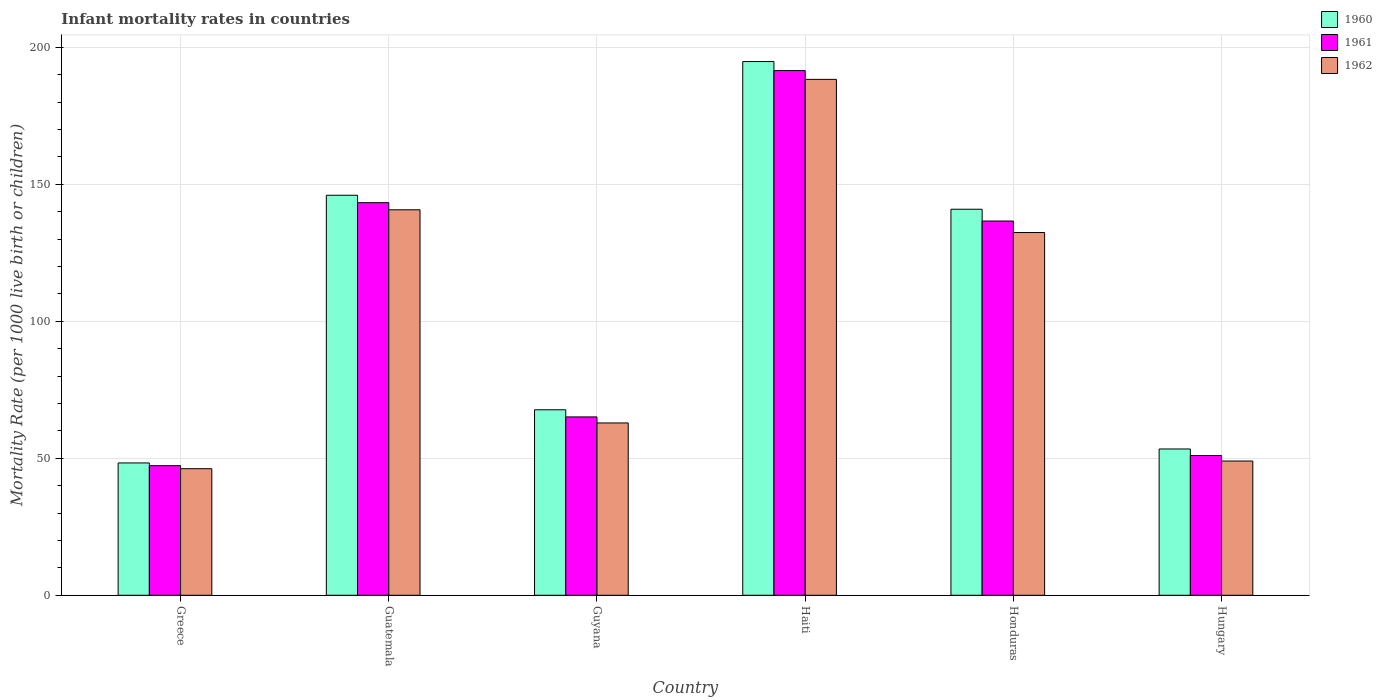How many different coloured bars are there?
Keep it short and to the point. 3. How many groups of bars are there?
Your answer should be compact. 6. Are the number of bars per tick equal to the number of legend labels?
Your answer should be compact. Yes. How many bars are there on the 1st tick from the right?
Provide a short and direct response. 3. What is the infant mortality rate in 1962 in Honduras?
Give a very brief answer. 132.4. Across all countries, what is the maximum infant mortality rate in 1960?
Offer a terse response. 194.8. Across all countries, what is the minimum infant mortality rate in 1961?
Ensure brevity in your answer.  47.3. In which country was the infant mortality rate in 1962 maximum?
Offer a very short reply. Haiti. In which country was the infant mortality rate in 1961 minimum?
Offer a very short reply. Greece. What is the total infant mortality rate in 1960 in the graph?
Ensure brevity in your answer.  651.1. What is the difference between the infant mortality rate in 1962 in Greece and that in Haiti?
Make the answer very short. -142.1. What is the difference between the infant mortality rate in 1961 in Greece and the infant mortality rate in 1960 in Guyana?
Keep it short and to the point. -20.4. What is the average infant mortality rate in 1962 per country?
Offer a terse response. 103.25. In how many countries, is the infant mortality rate in 1962 greater than 70?
Offer a terse response. 3. What is the ratio of the infant mortality rate in 1961 in Greece to that in Haiti?
Provide a succinct answer. 0.25. Is the difference between the infant mortality rate in 1962 in Greece and Guatemala greater than the difference between the infant mortality rate in 1960 in Greece and Guatemala?
Offer a very short reply. Yes. What is the difference between the highest and the second highest infant mortality rate in 1960?
Your answer should be compact. 53.9. What is the difference between the highest and the lowest infant mortality rate in 1961?
Offer a terse response. 144.2. In how many countries, is the infant mortality rate in 1961 greater than the average infant mortality rate in 1961 taken over all countries?
Your answer should be very brief. 3. What does the 1st bar from the right in Honduras represents?
Ensure brevity in your answer.  1962. Is it the case that in every country, the sum of the infant mortality rate in 1960 and infant mortality rate in 1961 is greater than the infant mortality rate in 1962?
Provide a short and direct response. Yes. How many countries are there in the graph?
Your answer should be very brief. 6. What is the difference between two consecutive major ticks on the Y-axis?
Offer a very short reply. 50. Are the values on the major ticks of Y-axis written in scientific E-notation?
Offer a very short reply. No. Does the graph contain any zero values?
Provide a short and direct response. No. How are the legend labels stacked?
Your answer should be very brief. Vertical. What is the title of the graph?
Offer a very short reply. Infant mortality rates in countries. What is the label or title of the X-axis?
Provide a succinct answer. Country. What is the label or title of the Y-axis?
Provide a succinct answer. Mortality Rate (per 1000 live birth or children). What is the Mortality Rate (per 1000 live birth or children) in 1960 in Greece?
Your answer should be compact. 48.3. What is the Mortality Rate (per 1000 live birth or children) in 1961 in Greece?
Give a very brief answer. 47.3. What is the Mortality Rate (per 1000 live birth or children) of 1962 in Greece?
Offer a very short reply. 46.2. What is the Mortality Rate (per 1000 live birth or children) of 1960 in Guatemala?
Make the answer very short. 146. What is the Mortality Rate (per 1000 live birth or children) of 1961 in Guatemala?
Your answer should be compact. 143.3. What is the Mortality Rate (per 1000 live birth or children) of 1962 in Guatemala?
Your answer should be compact. 140.7. What is the Mortality Rate (per 1000 live birth or children) of 1960 in Guyana?
Make the answer very short. 67.7. What is the Mortality Rate (per 1000 live birth or children) of 1961 in Guyana?
Provide a short and direct response. 65.1. What is the Mortality Rate (per 1000 live birth or children) in 1962 in Guyana?
Offer a very short reply. 62.9. What is the Mortality Rate (per 1000 live birth or children) in 1960 in Haiti?
Make the answer very short. 194.8. What is the Mortality Rate (per 1000 live birth or children) of 1961 in Haiti?
Your response must be concise. 191.5. What is the Mortality Rate (per 1000 live birth or children) in 1962 in Haiti?
Your answer should be very brief. 188.3. What is the Mortality Rate (per 1000 live birth or children) of 1960 in Honduras?
Your answer should be very brief. 140.9. What is the Mortality Rate (per 1000 live birth or children) of 1961 in Honduras?
Give a very brief answer. 136.6. What is the Mortality Rate (per 1000 live birth or children) of 1962 in Honduras?
Offer a very short reply. 132.4. What is the Mortality Rate (per 1000 live birth or children) in 1960 in Hungary?
Make the answer very short. 53.4. What is the Mortality Rate (per 1000 live birth or children) of 1962 in Hungary?
Your answer should be very brief. 49. Across all countries, what is the maximum Mortality Rate (per 1000 live birth or children) in 1960?
Your answer should be very brief. 194.8. Across all countries, what is the maximum Mortality Rate (per 1000 live birth or children) in 1961?
Provide a succinct answer. 191.5. Across all countries, what is the maximum Mortality Rate (per 1000 live birth or children) in 1962?
Provide a succinct answer. 188.3. Across all countries, what is the minimum Mortality Rate (per 1000 live birth or children) in 1960?
Offer a very short reply. 48.3. Across all countries, what is the minimum Mortality Rate (per 1000 live birth or children) of 1961?
Keep it short and to the point. 47.3. Across all countries, what is the minimum Mortality Rate (per 1000 live birth or children) in 1962?
Offer a terse response. 46.2. What is the total Mortality Rate (per 1000 live birth or children) of 1960 in the graph?
Your answer should be compact. 651.1. What is the total Mortality Rate (per 1000 live birth or children) in 1961 in the graph?
Make the answer very short. 634.8. What is the total Mortality Rate (per 1000 live birth or children) of 1962 in the graph?
Keep it short and to the point. 619.5. What is the difference between the Mortality Rate (per 1000 live birth or children) of 1960 in Greece and that in Guatemala?
Your response must be concise. -97.7. What is the difference between the Mortality Rate (per 1000 live birth or children) of 1961 in Greece and that in Guatemala?
Give a very brief answer. -96. What is the difference between the Mortality Rate (per 1000 live birth or children) in 1962 in Greece and that in Guatemala?
Your answer should be compact. -94.5. What is the difference between the Mortality Rate (per 1000 live birth or children) in 1960 in Greece and that in Guyana?
Provide a short and direct response. -19.4. What is the difference between the Mortality Rate (per 1000 live birth or children) of 1961 in Greece and that in Guyana?
Keep it short and to the point. -17.8. What is the difference between the Mortality Rate (per 1000 live birth or children) in 1962 in Greece and that in Guyana?
Give a very brief answer. -16.7. What is the difference between the Mortality Rate (per 1000 live birth or children) in 1960 in Greece and that in Haiti?
Give a very brief answer. -146.5. What is the difference between the Mortality Rate (per 1000 live birth or children) in 1961 in Greece and that in Haiti?
Give a very brief answer. -144.2. What is the difference between the Mortality Rate (per 1000 live birth or children) of 1962 in Greece and that in Haiti?
Give a very brief answer. -142.1. What is the difference between the Mortality Rate (per 1000 live birth or children) of 1960 in Greece and that in Honduras?
Your answer should be very brief. -92.6. What is the difference between the Mortality Rate (per 1000 live birth or children) of 1961 in Greece and that in Honduras?
Your answer should be compact. -89.3. What is the difference between the Mortality Rate (per 1000 live birth or children) of 1962 in Greece and that in Honduras?
Your answer should be very brief. -86.2. What is the difference between the Mortality Rate (per 1000 live birth or children) of 1960 in Greece and that in Hungary?
Offer a very short reply. -5.1. What is the difference between the Mortality Rate (per 1000 live birth or children) of 1962 in Greece and that in Hungary?
Provide a succinct answer. -2.8. What is the difference between the Mortality Rate (per 1000 live birth or children) in 1960 in Guatemala and that in Guyana?
Your answer should be very brief. 78.3. What is the difference between the Mortality Rate (per 1000 live birth or children) of 1961 in Guatemala and that in Guyana?
Provide a short and direct response. 78.2. What is the difference between the Mortality Rate (per 1000 live birth or children) in 1962 in Guatemala and that in Guyana?
Your response must be concise. 77.8. What is the difference between the Mortality Rate (per 1000 live birth or children) in 1960 in Guatemala and that in Haiti?
Provide a succinct answer. -48.8. What is the difference between the Mortality Rate (per 1000 live birth or children) of 1961 in Guatemala and that in Haiti?
Your response must be concise. -48.2. What is the difference between the Mortality Rate (per 1000 live birth or children) in 1962 in Guatemala and that in Haiti?
Offer a very short reply. -47.6. What is the difference between the Mortality Rate (per 1000 live birth or children) of 1962 in Guatemala and that in Honduras?
Your response must be concise. 8.3. What is the difference between the Mortality Rate (per 1000 live birth or children) of 1960 in Guatemala and that in Hungary?
Provide a succinct answer. 92.6. What is the difference between the Mortality Rate (per 1000 live birth or children) in 1961 in Guatemala and that in Hungary?
Provide a short and direct response. 92.3. What is the difference between the Mortality Rate (per 1000 live birth or children) of 1962 in Guatemala and that in Hungary?
Offer a terse response. 91.7. What is the difference between the Mortality Rate (per 1000 live birth or children) in 1960 in Guyana and that in Haiti?
Ensure brevity in your answer.  -127.1. What is the difference between the Mortality Rate (per 1000 live birth or children) in 1961 in Guyana and that in Haiti?
Keep it short and to the point. -126.4. What is the difference between the Mortality Rate (per 1000 live birth or children) in 1962 in Guyana and that in Haiti?
Make the answer very short. -125.4. What is the difference between the Mortality Rate (per 1000 live birth or children) of 1960 in Guyana and that in Honduras?
Provide a short and direct response. -73.2. What is the difference between the Mortality Rate (per 1000 live birth or children) in 1961 in Guyana and that in Honduras?
Your response must be concise. -71.5. What is the difference between the Mortality Rate (per 1000 live birth or children) in 1962 in Guyana and that in Honduras?
Provide a short and direct response. -69.5. What is the difference between the Mortality Rate (per 1000 live birth or children) in 1960 in Haiti and that in Honduras?
Give a very brief answer. 53.9. What is the difference between the Mortality Rate (per 1000 live birth or children) in 1961 in Haiti and that in Honduras?
Keep it short and to the point. 54.9. What is the difference between the Mortality Rate (per 1000 live birth or children) of 1962 in Haiti and that in Honduras?
Make the answer very short. 55.9. What is the difference between the Mortality Rate (per 1000 live birth or children) of 1960 in Haiti and that in Hungary?
Make the answer very short. 141.4. What is the difference between the Mortality Rate (per 1000 live birth or children) in 1961 in Haiti and that in Hungary?
Your answer should be very brief. 140.5. What is the difference between the Mortality Rate (per 1000 live birth or children) in 1962 in Haiti and that in Hungary?
Keep it short and to the point. 139.3. What is the difference between the Mortality Rate (per 1000 live birth or children) in 1960 in Honduras and that in Hungary?
Your answer should be very brief. 87.5. What is the difference between the Mortality Rate (per 1000 live birth or children) in 1961 in Honduras and that in Hungary?
Ensure brevity in your answer.  85.6. What is the difference between the Mortality Rate (per 1000 live birth or children) in 1962 in Honduras and that in Hungary?
Make the answer very short. 83.4. What is the difference between the Mortality Rate (per 1000 live birth or children) of 1960 in Greece and the Mortality Rate (per 1000 live birth or children) of 1961 in Guatemala?
Keep it short and to the point. -95. What is the difference between the Mortality Rate (per 1000 live birth or children) in 1960 in Greece and the Mortality Rate (per 1000 live birth or children) in 1962 in Guatemala?
Provide a succinct answer. -92.4. What is the difference between the Mortality Rate (per 1000 live birth or children) in 1961 in Greece and the Mortality Rate (per 1000 live birth or children) in 1962 in Guatemala?
Provide a succinct answer. -93.4. What is the difference between the Mortality Rate (per 1000 live birth or children) in 1960 in Greece and the Mortality Rate (per 1000 live birth or children) in 1961 in Guyana?
Keep it short and to the point. -16.8. What is the difference between the Mortality Rate (per 1000 live birth or children) in 1960 in Greece and the Mortality Rate (per 1000 live birth or children) in 1962 in Guyana?
Make the answer very short. -14.6. What is the difference between the Mortality Rate (per 1000 live birth or children) of 1961 in Greece and the Mortality Rate (per 1000 live birth or children) of 1962 in Guyana?
Make the answer very short. -15.6. What is the difference between the Mortality Rate (per 1000 live birth or children) of 1960 in Greece and the Mortality Rate (per 1000 live birth or children) of 1961 in Haiti?
Offer a very short reply. -143.2. What is the difference between the Mortality Rate (per 1000 live birth or children) of 1960 in Greece and the Mortality Rate (per 1000 live birth or children) of 1962 in Haiti?
Provide a short and direct response. -140. What is the difference between the Mortality Rate (per 1000 live birth or children) in 1961 in Greece and the Mortality Rate (per 1000 live birth or children) in 1962 in Haiti?
Offer a very short reply. -141. What is the difference between the Mortality Rate (per 1000 live birth or children) in 1960 in Greece and the Mortality Rate (per 1000 live birth or children) in 1961 in Honduras?
Provide a succinct answer. -88.3. What is the difference between the Mortality Rate (per 1000 live birth or children) of 1960 in Greece and the Mortality Rate (per 1000 live birth or children) of 1962 in Honduras?
Offer a very short reply. -84.1. What is the difference between the Mortality Rate (per 1000 live birth or children) in 1961 in Greece and the Mortality Rate (per 1000 live birth or children) in 1962 in Honduras?
Your answer should be compact. -85.1. What is the difference between the Mortality Rate (per 1000 live birth or children) in 1960 in Greece and the Mortality Rate (per 1000 live birth or children) in 1961 in Hungary?
Your answer should be very brief. -2.7. What is the difference between the Mortality Rate (per 1000 live birth or children) in 1960 in Greece and the Mortality Rate (per 1000 live birth or children) in 1962 in Hungary?
Give a very brief answer. -0.7. What is the difference between the Mortality Rate (per 1000 live birth or children) in 1960 in Guatemala and the Mortality Rate (per 1000 live birth or children) in 1961 in Guyana?
Keep it short and to the point. 80.9. What is the difference between the Mortality Rate (per 1000 live birth or children) of 1960 in Guatemala and the Mortality Rate (per 1000 live birth or children) of 1962 in Guyana?
Provide a short and direct response. 83.1. What is the difference between the Mortality Rate (per 1000 live birth or children) in 1961 in Guatemala and the Mortality Rate (per 1000 live birth or children) in 1962 in Guyana?
Provide a short and direct response. 80.4. What is the difference between the Mortality Rate (per 1000 live birth or children) in 1960 in Guatemala and the Mortality Rate (per 1000 live birth or children) in 1961 in Haiti?
Make the answer very short. -45.5. What is the difference between the Mortality Rate (per 1000 live birth or children) in 1960 in Guatemala and the Mortality Rate (per 1000 live birth or children) in 1962 in Haiti?
Offer a terse response. -42.3. What is the difference between the Mortality Rate (per 1000 live birth or children) in 1961 in Guatemala and the Mortality Rate (per 1000 live birth or children) in 1962 in Haiti?
Make the answer very short. -45. What is the difference between the Mortality Rate (per 1000 live birth or children) in 1960 in Guatemala and the Mortality Rate (per 1000 live birth or children) in 1962 in Honduras?
Give a very brief answer. 13.6. What is the difference between the Mortality Rate (per 1000 live birth or children) in 1961 in Guatemala and the Mortality Rate (per 1000 live birth or children) in 1962 in Honduras?
Your answer should be very brief. 10.9. What is the difference between the Mortality Rate (per 1000 live birth or children) in 1960 in Guatemala and the Mortality Rate (per 1000 live birth or children) in 1962 in Hungary?
Ensure brevity in your answer.  97. What is the difference between the Mortality Rate (per 1000 live birth or children) in 1961 in Guatemala and the Mortality Rate (per 1000 live birth or children) in 1962 in Hungary?
Provide a succinct answer. 94.3. What is the difference between the Mortality Rate (per 1000 live birth or children) of 1960 in Guyana and the Mortality Rate (per 1000 live birth or children) of 1961 in Haiti?
Your answer should be very brief. -123.8. What is the difference between the Mortality Rate (per 1000 live birth or children) of 1960 in Guyana and the Mortality Rate (per 1000 live birth or children) of 1962 in Haiti?
Your answer should be very brief. -120.6. What is the difference between the Mortality Rate (per 1000 live birth or children) of 1961 in Guyana and the Mortality Rate (per 1000 live birth or children) of 1962 in Haiti?
Keep it short and to the point. -123.2. What is the difference between the Mortality Rate (per 1000 live birth or children) of 1960 in Guyana and the Mortality Rate (per 1000 live birth or children) of 1961 in Honduras?
Offer a very short reply. -68.9. What is the difference between the Mortality Rate (per 1000 live birth or children) in 1960 in Guyana and the Mortality Rate (per 1000 live birth or children) in 1962 in Honduras?
Offer a very short reply. -64.7. What is the difference between the Mortality Rate (per 1000 live birth or children) in 1961 in Guyana and the Mortality Rate (per 1000 live birth or children) in 1962 in Honduras?
Ensure brevity in your answer.  -67.3. What is the difference between the Mortality Rate (per 1000 live birth or children) of 1960 in Haiti and the Mortality Rate (per 1000 live birth or children) of 1961 in Honduras?
Make the answer very short. 58.2. What is the difference between the Mortality Rate (per 1000 live birth or children) in 1960 in Haiti and the Mortality Rate (per 1000 live birth or children) in 1962 in Honduras?
Provide a short and direct response. 62.4. What is the difference between the Mortality Rate (per 1000 live birth or children) of 1961 in Haiti and the Mortality Rate (per 1000 live birth or children) of 1962 in Honduras?
Provide a succinct answer. 59.1. What is the difference between the Mortality Rate (per 1000 live birth or children) of 1960 in Haiti and the Mortality Rate (per 1000 live birth or children) of 1961 in Hungary?
Provide a succinct answer. 143.8. What is the difference between the Mortality Rate (per 1000 live birth or children) of 1960 in Haiti and the Mortality Rate (per 1000 live birth or children) of 1962 in Hungary?
Offer a very short reply. 145.8. What is the difference between the Mortality Rate (per 1000 live birth or children) in 1961 in Haiti and the Mortality Rate (per 1000 live birth or children) in 1962 in Hungary?
Your answer should be compact. 142.5. What is the difference between the Mortality Rate (per 1000 live birth or children) in 1960 in Honduras and the Mortality Rate (per 1000 live birth or children) in 1961 in Hungary?
Keep it short and to the point. 89.9. What is the difference between the Mortality Rate (per 1000 live birth or children) of 1960 in Honduras and the Mortality Rate (per 1000 live birth or children) of 1962 in Hungary?
Offer a very short reply. 91.9. What is the difference between the Mortality Rate (per 1000 live birth or children) in 1961 in Honduras and the Mortality Rate (per 1000 live birth or children) in 1962 in Hungary?
Your response must be concise. 87.6. What is the average Mortality Rate (per 1000 live birth or children) of 1960 per country?
Give a very brief answer. 108.52. What is the average Mortality Rate (per 1000 live birth or children) in 1961 per country?
Provide a short and direct response. 105.8. What is the average Mortality Rate (per 1000 live birth or children) of 1962 per country?
Your answer should be compact. 103.25. What is the difference between the Mortality Rate (per 1000 live birth or children) of 1960 and Mortality Rate (per 1000 live birth or children) of 1961 in Greece?
Make the answer very short. 1. What is the difference between the Mortality Rate (per 1000 live birth or children) in 1960 and Mortality Rate (per 1000 live birth or children) in 1962 in Greece?
Your response must be concise. 2.1. What is the difference between the Mortality Rate (per 1000 live birth or children) in 1961 and Mortality Rate (per 1000 live birth or children) in 1962 in Greece?
Keep it short and to the point. 1.1. What is the difference between the Mortality Rate (per 1000 live birth or children) in 1960 and Mortality Rate (per 1000 live birth or children) in 1961 in Guatemala?
Ensure brevity in your answer.  2.7. What is the difference between the Mortality Rate (per 1000 live birth or children) in 1960 and Mortality Rate (per 1000 live birth or children) in 1962 in Guatemala?
Make the answer very short. 5.3. What is the difference between the Mortality Rate (per 1000 live birth or children) in 1961 and Mortality Rate (per 1000 live birth or children) in 1962 in Guatemala?
Ensure brevity in your answer.  2.6. What is the difference between the Mortality Rate (per 1000 live birth or children) in 1961 and Mortality Rate (per 1000 live birth or children) in 1962 in Guyana?
Ensure brevity in your answer.  2.2. What is the difference between the Mortality Rate (per 1000 live birth or children) of 1961 and Mortality Rate (per 1000 live birth or children) of 1962 in Haiti?
Keep it short and to the point. 3.2. What is the difference between the Mortality Rate (per 1000 live birth or children) of 1960 and Mortality Rate (per 1000 live birth or children) of 1962 in Honduras?
Keep it short and to the point. 8.5. What is the difference between the Mortality Rate (per 1000 live birth or children) in 1960 and Mortality Rate (per 1000 live birth or children) in 1961 in Hungary?
Provide a succinct answer. 2.4. What is the ratio of the Mortality Rate (per 1000 live birth or children) of 1960 in Greece to that in Guatemala?
Offer a terse response. 0.33. What is the ratio of the Mortality Rate (per 1000 live birth or children) of 1961 in Greece to that in Guatemala?
Your answer should be compact. 0.33. What is the ratio of the Mortality Rate (per 1000 live birth or children) of 1962 in Greece to that in Guatemala?
Your answer should be compact. 0.33. What is the ratio of the Mortality Rate (per 1000 live birth or children) in 1960 in Greece to that in Guyana?
Your response must be concise. 0.71. What is the ratio of the Mortality Rate (per 1000 live birth or children) of 1961 in Greece to that in Guyana?
Make the answer very short. 0.73. What is the ratio of the Mortality Rate (per 1000 live birth or children) of 1962 in Greece to that in Guyana?
Ensure brevity in your answer.  0.73. What is the ratio of the Mortality Rate (per 1000 live birth or children) in 1960 in Greece to that in Haiti?
Your answer should be very brief. 0.25. What is the ratio of the Mortality Rate (per 1000 live birth or children) of 1961 in Greece to that in Haiti?
Your answer should be compact. 0.25. What is the ratio of the Mortality Rate (per 1000 live birth or children) of 1962 in Greece to that in Haiti?
Keep it short and to the point. 0.25. What is the ratio of the Mortality Rate (per 1000 live birth or children) of 1960 in Greece to that in Honduras?
Make the answer very short. 0.34. What is the ratio of the Mortality Rate (per 1000 live birth or children) of 1961 in Greece to that in Honduras?
Keep it short and to the point. 0.35. What is the ratio of the Mortality Rate (per 1000 live birth or children) in 1962 in Greece to that in Honduras?
Offer a very short reply. 0.35. What is the ratio of the Mortality Rate (per 1000 live birth or children) of 1960 in Greece to that in Hungary?
Provide a short and direct response. 0.9. What is the ratio of the Mortality Rate (per 1000 live birth or children) of 1961 in Greece to that in Hungary?
Give a very brief answer. 0.93. What is the ratio of the Mortality Rate (per 1000 live birth or children) in 1962 in Greece to that in Hungary?
Offer a very short reply. 0.94. What is the ratio of the Mortality Rate (per 1000 live birth or children) of 1960 in Guatemala to that in Guyana?
Offer a terse response. 2.16. What is the ratio of the Mortality Rate (per 1000 live birth or children) of 1961 in Guatemala to that in Guyana?
Make the answer very short. 2.2. What is the ratio of the Mortality Rate (per 1000 live birth or children) in 1962 in Guatemala to that in Guyana?
Your answer should be very brief. 2.24. What is the ratio of the Mortality Rate (per 1000 live birth or children) in 1960 in Guatemala to that in Haiti?
Give a very brief answer. 0.75. What is the ratio of the Mortality Rate (per 1000 live birth or children) of 1961 in Guatemala to that in Haiti?
Your answer should be compact. 0.75. What is the ratio of the Mortality Rate (per 1000 live birth or children) in 1962 in Guatemala to that in Haiti?
Provide a succinct answer. 0.75. What is the ratio of the Mortality Rate (per 1000 live birth or children) of 1960 in Guatemala to that in Honduras?
Ensure brevity in your answer.  1.04. What is the ratio of the Mortality Rate (per 1000 live birth or children) in 1961 in Guatemala to that in Honduras?
Give a very brief answer. 1.05. What is the ratio of the Mortality Rate (per 1000 live birth or children) in 1962 in Guatemala to that in Honduras?
Your answer should be very brief. 1.06. What is the ratio of the Mortality Rate (per 1000 live birth or children) of 1960 in Guatemala to that in Hungary?
Your answer should be very brief. 2.73. What is the ratio of the Mortality Rate (per 1000 live birth or children) in 1961 in Guatemala to that in Hungary?
Offer a very short reply. 2.81. What is the ratio of the Mortality Rate (per 1000 live birth or children) of 1962 in Guatemala to that in Hungary?
Keep it short and to the point. 2.87. What is the ratio of the Mortality Rate (per 1000 live birth or children) in 1960 in Guyana to that in Haiti?
Give a very brief answer. 0.35. What is the ratio of the Mortality Rate (per 1000 live birth or children) in 1961 in Guyana to that in Haiti?
Give a very brief answer. 0.34. What is the ratio of the Mortality Rate (per 1000 live birth or children) of 1962 in Guyana to that in Haiti?
Your response must be concise. 0.33. What is the ratio of the Mortality Rate (per 1000 live birth or children) in 1960 in Guyana to that in Honduras?
Your response must be concise. 0.48. What is the ratio of the Mortality Rate (per 1000 live birth or children) of 1961 in Guyana to that in Honduras?
Your response must be concise. 0.48. What is the ratio of the Mortality Rate (per 1000 live birth or children) in 1962 in Guyana to that in Honduras?
Offer a very short reply. 0.48. What is the ratio of the Mortality Rate (per 1000 live birth or children) in 1960 in Guyana to that in Hungary?
Provide a short and direct response. 1.27. What is the ratio of the Mortality Rate (per 1000 live birth or children) in 1961 in Guyana to that in Hungary?
Offer a terse response. 1.28. What is the ratio of the Mortality Rate (per 1000 live birth or children) of 1962 in Guyana to that in Hungary?
Give a very brief answer. 1.28. What is the ratio of the Mortality Rate (per 1000 live birth or children) in 1960 in Haiti to that in Honduras?
Your answer should be very brief. 1.38. What is the ratio of the Mortality Rate (per 1000 live birth or children) in 1961 in Haiti to that in Honduras?
Provide a succinct answer. 1.4. What is the ratio of the Mortality Rate (per 1000 live birth or children) in 1962 in Haiti to that in Honduras?
Your answer should be very brief. 1.42. What is the ratio of the Mortality Rate (per 1000 live birth or children) in 1960 in Haiti to that in Hungary?
Your response must be concise. 3.65. What is the ratio of the Mortality Rate (per 1000 live birth or children) in 1961 in Haiti to that in Hungary?
Provide a short and direct response. 3.75. What is the ratio of the Mortality Rate (per 1000 live birth or children) in 1962 in Haiti to that in Hungary?
Ensure brevity in your answer.  3.84. What is the ratio of the Mortality Rate (per 1000 live birth or children) of 1960 in Honduras to that in Hungary?
Your answer should be compact. 2.64. What is the ratio of the Mortality Rate (per 1000 live birth or children) of 1961 in Honduras to that in Hungary?
Provide a short and direct response. 2.68. What is the ratio of the Mortality Rate (per 1000 live birth or children) of 1962 in Honduras to that in Hungary?
Offer a very short reply. 2.7. What is the difference between the highest and the second highest Mortality Rate (per 1000 live birth or children) in 1960?
Offer a terse response. 48.8. What is the difference between the highest and the second highest Mortality Rate (per 1000 live birth or children) in 1961?
Give a very brief answer. 48.2. What is the difference between the highest and the second highest Mortality Rate (per 1000 live birth or children) of 1962?
Offer a terse response. 47.6. What is the difference between the highest and the lowest Mortality Rate (per 1000 live birth or children) in 1960?
Offer a very short reply. 146.5. What is the difference between the highest and the lowest Mortality Rate (per 1000 live birth or children) of 1961?
Provide a succinct answer. 144.2. What is the difference between the highest and the lowest Mortality Rate (per 1000 live birth or children) in 1962?
Ensure brevity in your answer.  142.1. 